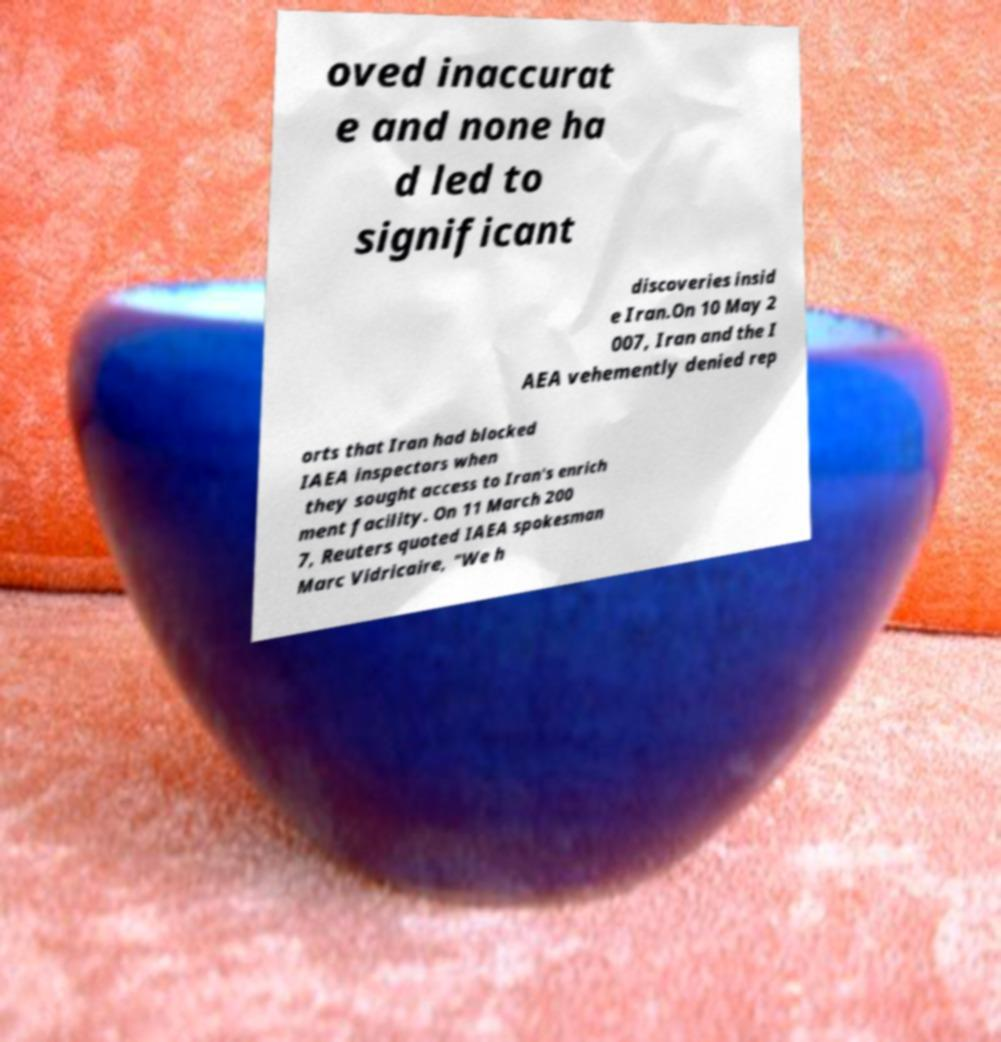I need the written content from this picture converted into text. Can you do that? oved inaccurat e and none ha d led to significant discoveries insid e Iran.On 10 May 2 007, Iran and the I AEA vehemently denied rep orts that Iran had blocked IAEA inspectors when they sought access to Iran's enrich ment facility. On 11 March 200 7, Reuters quoted IAEA spokesman Marc Vidricaire, "We h 